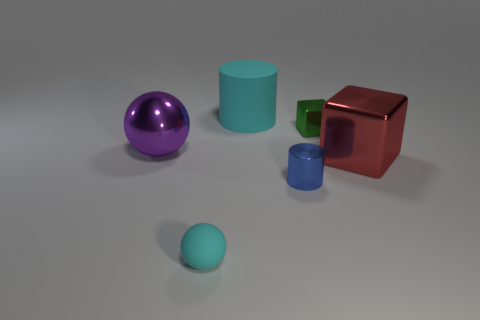Add 1 small shiny cylinders. How many objects exist? 7 Subtract all cylinders. How many objects are left? 4 Add 1 tiny cylinders. How many tiny cylinders exist? 2 Subtract 0 gray spheres. How many objects are left? 6 Subtract all rubber things. Subtract all small metal objects. How many objects are left? 2 Add 5 spheres. How many spheres are left? 7 